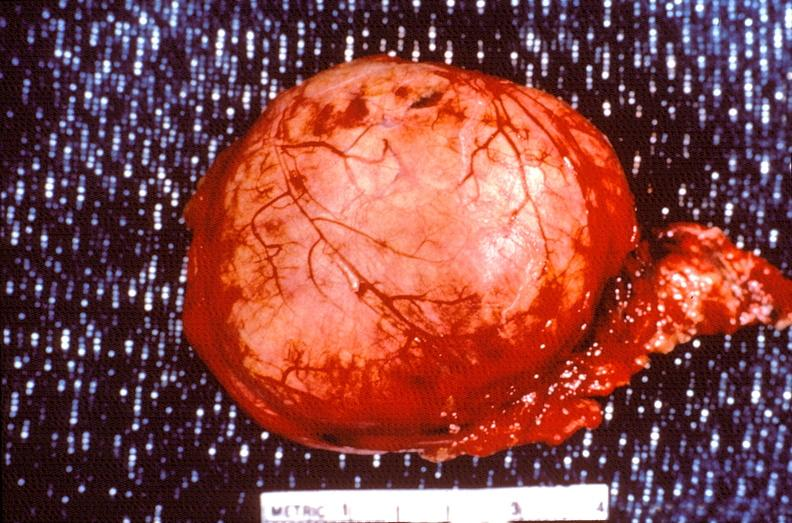what does this image show?
Answer the question using a single word or phrase. Pituitary 